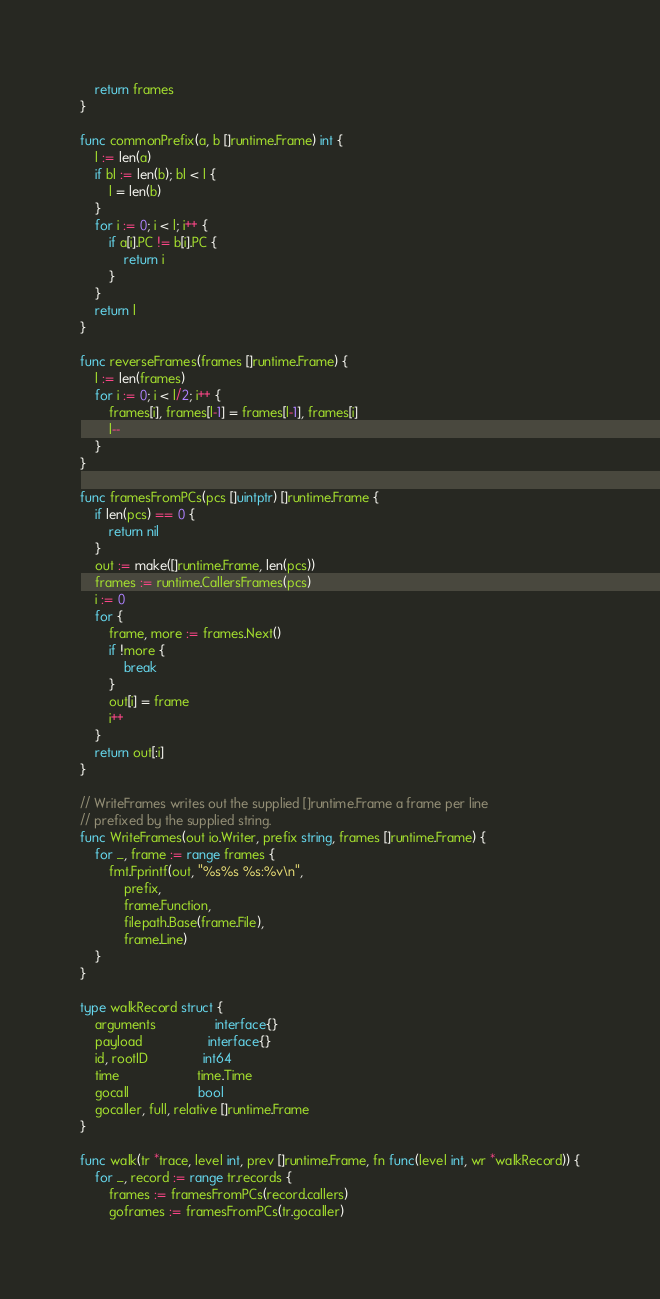Convert code to text. <code><loc_0><loc_0><loc_500><loc_500><_Go_>	return frames
}

func commonPrefix(a, b []runtime.Frame) int {
	l := len(a)
	if bl := len(b); bl < l {
		l = len(b)
	}
	for i := 0; i < l; i++ {
		if a[i].PC != b[i].PC {
			return i
		}
	}
	return l
}

func reverseFrames(frames []runtime.Frame) {
	l := len(frames)
	for i := 0; i < l/2; i++ {
		frames[i], frames[l-1] = frames[l-1], frames[i]
		l--
	}
}

func framesFromPCs(pcs []uintptr) []runtime.Frame {
	if len(pcs) == 0 {
		return nil
	}
	out := make([]runtime.Frame, len(pcs))
	frames := runtime.CallersFrames(pcs)
	i := 0
	for {
		frame, more := frames.Next()
		if !more {
			break
		}
		out[i] = frame
		i++
	}
	return out[:i]
}

// WriteFrames writes out the supplied []runtime.Frame a frame per line
// prefixed by the supplied string.
func WriteFrames(out io.Writer, prefix string, frames []runtime.Frame) {
	for _, frame := range frames {
		fmt.Fprintf(out, "%s%s %s:%v\n",
			prefix,
			frame.Function,
			filepath.Base(frame.File),
			frame.Line)
	}
}

type walkRecord struct {
	arguments                interface{}
	payload                  interface{}
	id, rootID               int64
	time                     time.Time
	gocall                   bool
	gocaller, full, relative []runtime.Frame
}

func walk(tr *trace, level int, prev []runtime.Frame, fn func(level int, wr *walkRecord)) {
	for _, record := range tr.records {
		frames := framesFromPCs(record.callers)
		goframes := framesFromPCs(tr.gocaller)</code> 